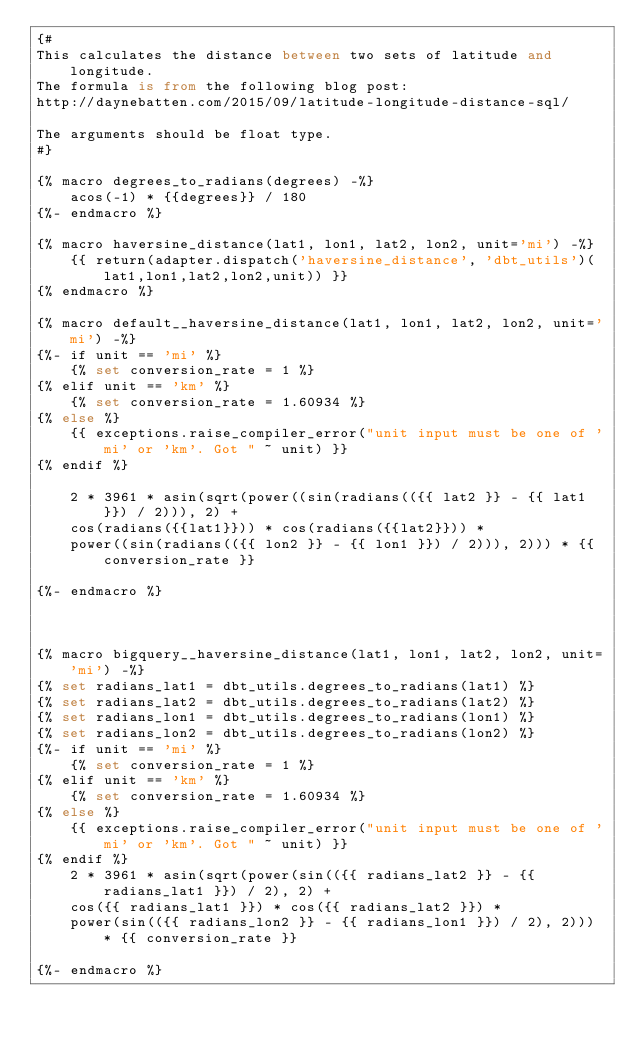Convert code to text. <code><loc_0><loc_0><loc_500><loc_500><_SQL_>{#
This calculates the distance between two sets of latitude and longitude.
The formula is from the following blog post:
http://daynebatten.com/2015/09/latitude-longitude-distance-sql/

The arguments should be float type.
#}

{% macro degrees_to_radians(degrees) -%}
    acos(-1) * {{degrees}} / 180
{%- endmacro %}

{% macro haversine_distance(lat1, lon1, lat2, lon2, unit='mi') -%}
    {{ return(adapter.dispatch('haversine_distance', 'dbt_utils')(lat1,lon1,lat2,lon2,unit)) }}
{% endmacro %}

{% macro default__haversine_distance(lat1, lon1, lat2, lon2, unit='mi') -%}
{%- if unit == 'mi' %}
    {% set conversion_rate = 1 %}
{% elif unit == 'km' %}
    {% set conversion_rate = 1.60934 %}
{% else %}
    {{ exceptions.raise_compiler_error("unit input must be one of 'mi' or 'km'. Got " ~ unit) }}
{% endif %}

    2 * 3961 * asin(sqrt(power((sin(radians(({{ lat2 }} - {{ lat1 }}) / 2))), 2) +
    cos(radians({{lat1}})) * cos(radians({{lat2}})) *
    power((sin(radians(({{ lon2 }} - {{ lon1 }}) / 2))), 2))) * {{ conversion_rate }}

{%- endmacro %}



{% macro bigquery__haversine_distance(lat1, lon1, lat2, lon2, unit='mi') -%}
{% set radians_lat1 = dbt_utils.degrees_to_radians(lat1) %}
{% set radians_lat2 = dbt_utils.degrees_to_radians(lat2) %}
{% set radians_lon1 = dbt_utils.degrees_to_radians(lon1) %}
{% set radians_lon2 = dbt_utils.degrees_to_radians(lon2) %}
{%- if unit == 'mi' %}
    {% set conversion_rate = 1 %}
{% elif unit == 'km' %}
    {% set conversion_rate = 1.60934 %}
{% else %}
    {{ exceptions.raise_compiler_error("unit input must be one of 'mi' or 'km'. Got " ~ unit) }}
{% endif %}
    2 * 3961 * asin(sqrt(power(sin(({{ radians_lat2 }} - {{ radians_lat1 }}) / 2), 2) +
    cos({{ radians_lat1 }}) * cos({{ radians_lat2 }}) *
    power(sin(({{ radians_lon2 }} - {{ radians_lon1 }}) / 2), 2))) * {{ conversion_rate }}

{%- endmacro %}

</code> 